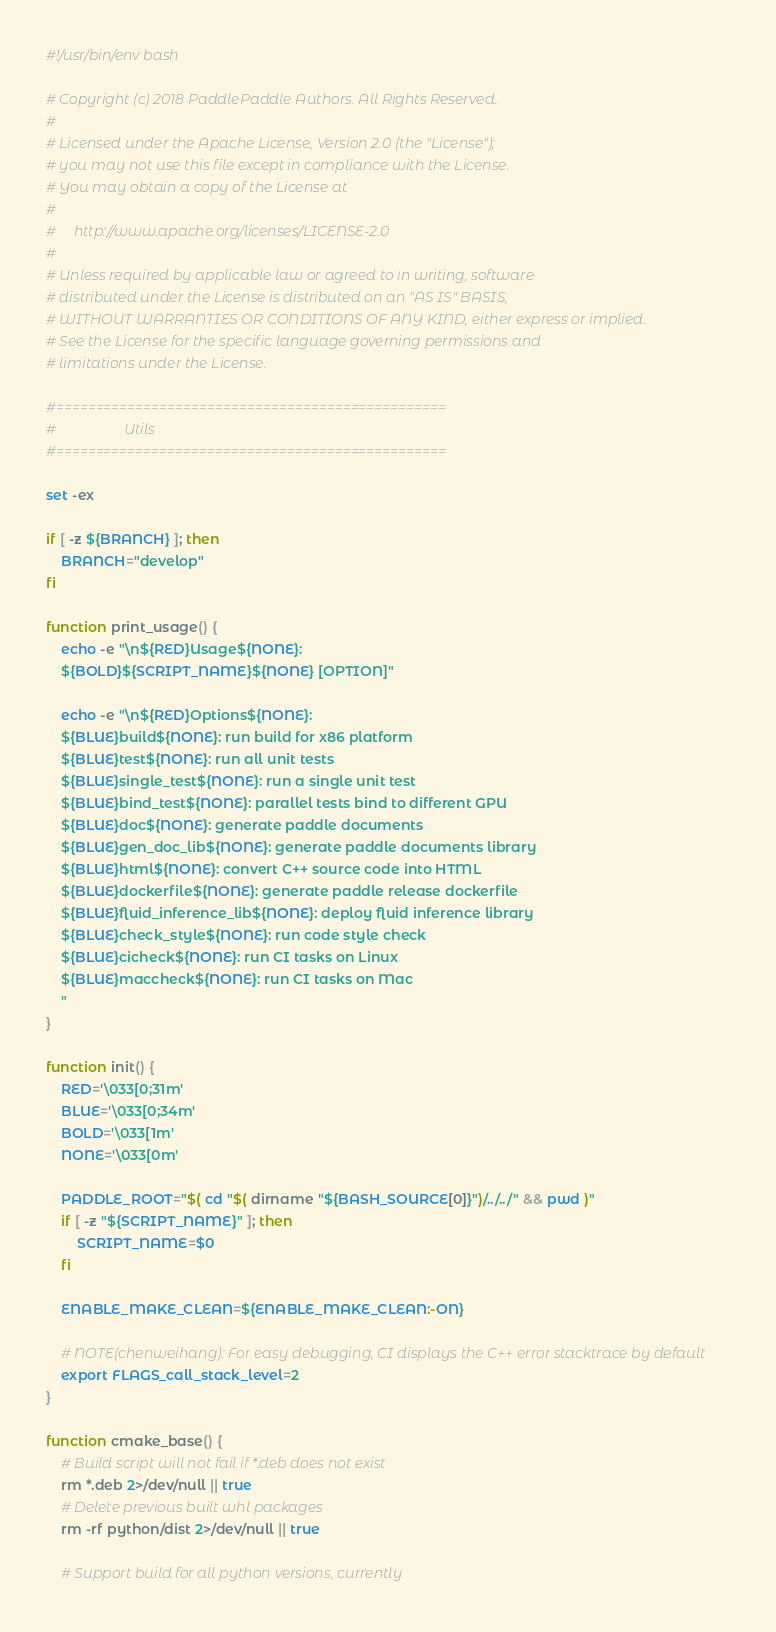<code> <loc_0><loc_0><loc_500><loc_500><_Bash_>#!/usr/bin/env bash

# Copyright (c) 2018 PaddlePaddle Authors. All Rights Reserved.
#
# Licensed under the Apache License, Version 2.0 (the "License");
# you may not use this file except in compliance with the License.
# You may obtain a copy of the License at
#
#     http://www.apache.org/licenses/LICENSE-2.0
#
# Unless required by applicable law or agreed to in writing, software
# distributed under the License is distributed on an "AS IS" BASIS,
# WITHOUT WARRANTIES OR CONDITIONS OF ANY KIND, either express or implied.
# See the License for the specific language governing permissions and
# limitations under the License.

#=================================================
#                   Utils
#=================================================

set -ex

if [ -z ${BRANCH} ]; then
    BRANCH="develop"
fi

function print_usage() {
    echo -e "\n${RED}Usage${NONE}:
    ${BOLD}${SCRIPT_NAME}${NONE} [OPTION]"

    echo -e "\n${RED}Options${NONE}:
    ${BLUE}build${NONE}: run build for x86 platform
    ${BLUE}test${NONE}: run all unit tests
    ${BLUE}single_test${NONE}: run a single unit test
    ${BLUE}bind_test${NONE}: parallel tests bind to different GPU
    ${BLUE}doc${NONE}: generate paddle documents
    ${BLUE}gen_doc_lib${NONE}: generate paddle documents library
    ${BLUE}html${NONE}: convert C++ source code into HTML
    ${BLUE}dockerfile${NONE}: generate paddle release dockerfile
    ${BLUE}fluid_inference_lib${NONE}: deploy fluid inference library
    ${BLUE}check_style${NONE}: run code style check
    ${BLUE}cicheck${NONE}: run CI tasks on Linux
    ${BLUE}maccheck${NONE}: run CI tasks on Mac
    "
}

function init() {
    RED='\033[0;31m'
    BLUE='\033[0;34m'
    BOLD='\033[1m'
    NONE='\033[0m'

    PADDLE_ROOT="$( cd "$( dirname "${BASH_SOURCE[0]}")/../../" && pwd )"
    if [ -z "${SCRIPT_NAME}" ]; then
        SCRIPT_NAME=$0
    fi

    ENABLE_MAKE_CLEAN=${ENABLE_MAKE_CLEAN:-ON}

    # NOTE(chenweihang): For easy debugging, CI displays the C++ error stacktrace by default 
    export FLAGS_call_stack_level=2
}

function cmake_base() {
    # Build script will not fail if *.deb does not exist
    rm *.deb 2>/dev/null || true
    # Delete previous built whl packages
    rm -rf python/dist 2>/dev/null || true

    # Support build for all python versions, currently</code> 